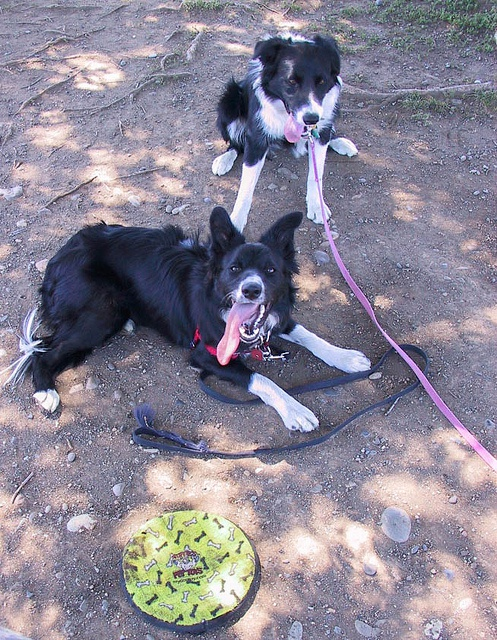Describe the objects in this image and their specific colors. I can see dog in darkgray, black, navy, gray, and lavender tones, dog in darkgray, lavender, navy, black, and gray tones, and frisbee in darkgray, khaki, beige, gray, and olive tones in this image. 